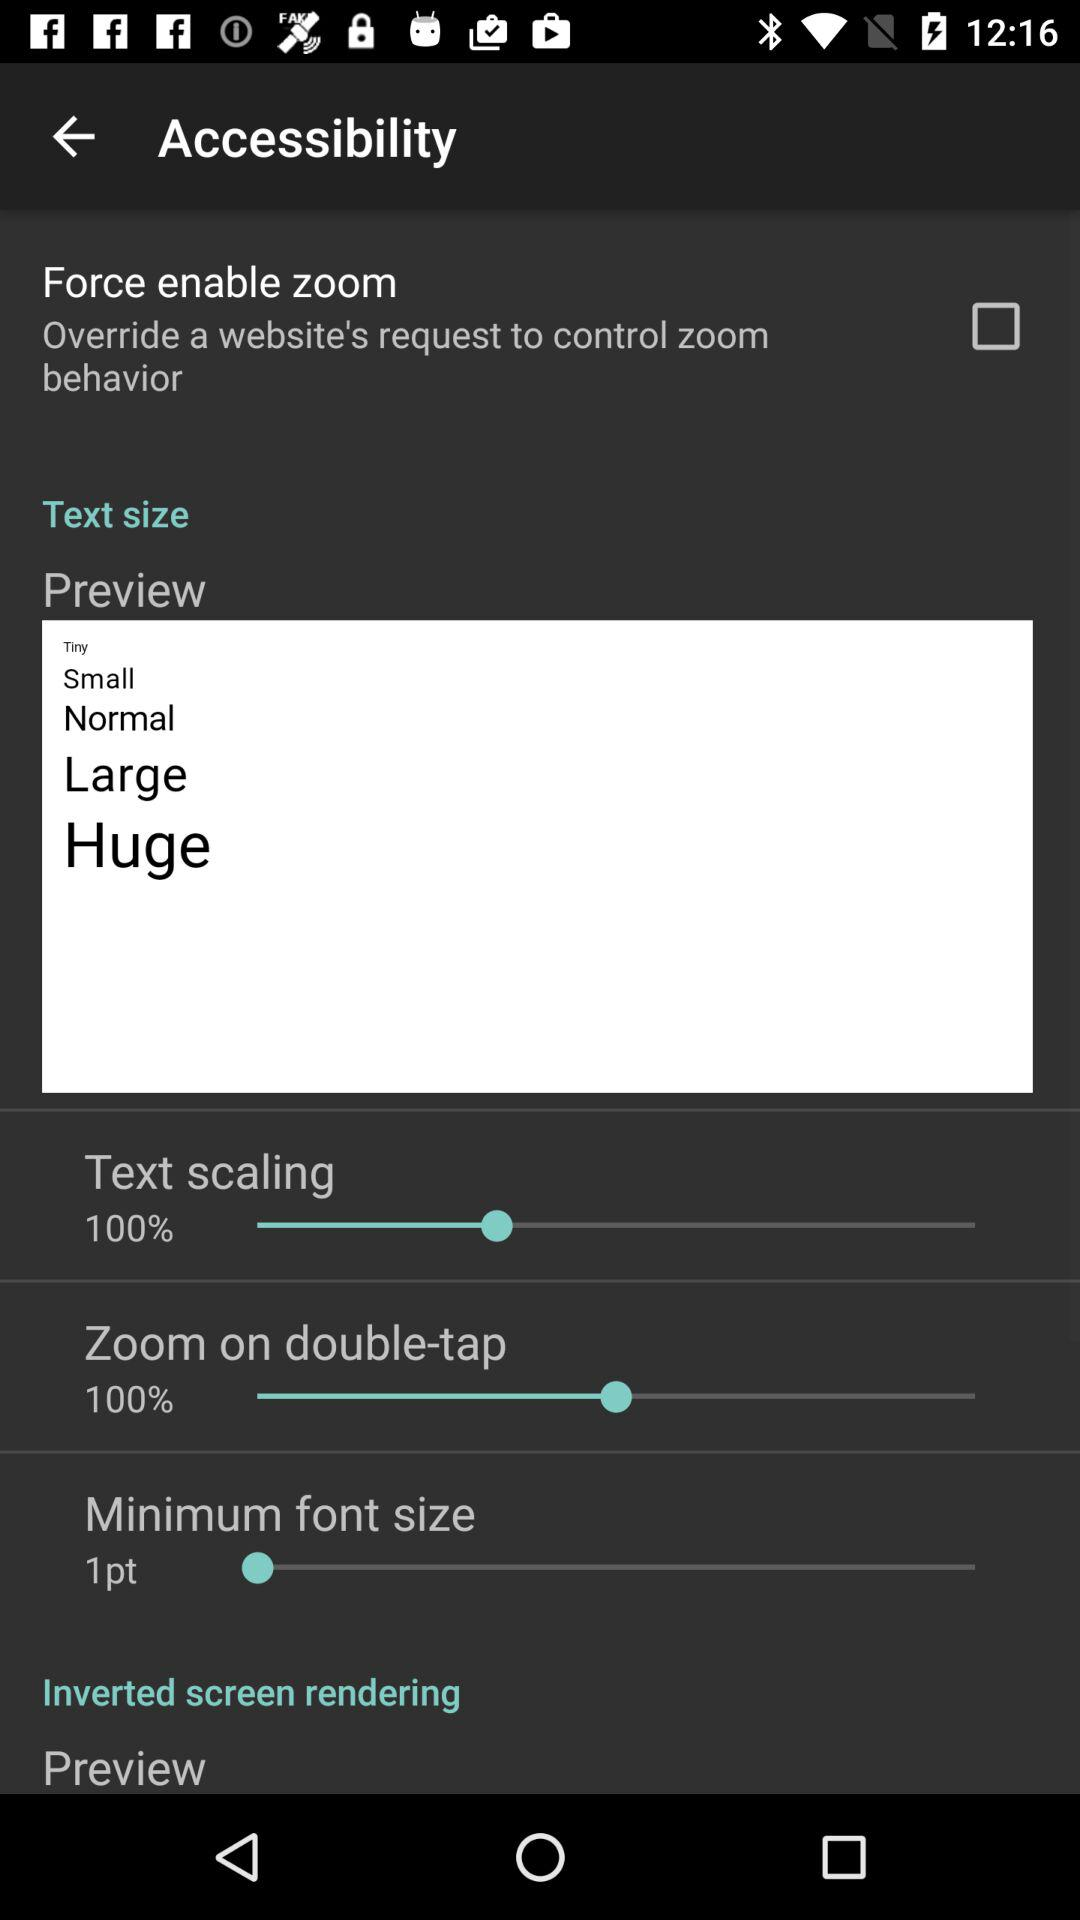What is the status of the "Force enable zoom"? The status is "off". 